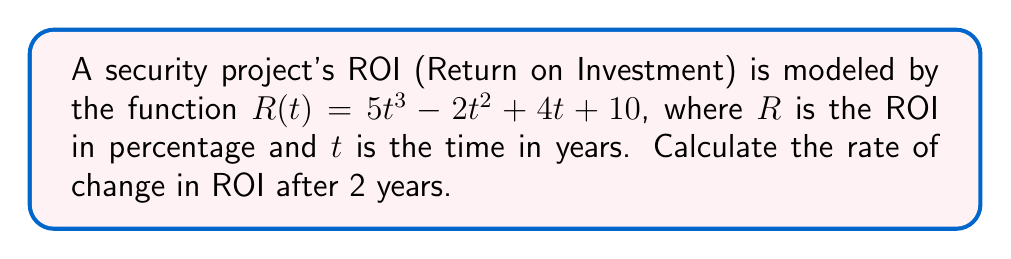Help me with this question. To find the rate of change in ROI after 2 years, we need to calculate the derivative of the ROI function and evaluate it at $t = 2$. Here's the step-by-step process:

1. Given ROI function: $R(t) = 5t^3 - 2t^2 + 4t + 10$

2. Calculate the derivative $R'(t)$:
   $$R'(t) = \frac{d}{dt}(5t^3 - 2t^2 + 4t + 10)$$
   $$R'(t) = 15t^2 - 4t + 4$$

3. Evaluate $R'(t)$ at $t = 2$:
   $$R'(2) = 15(2)^2 - 4(2) + 4$$
   $$R'(2) = 15(4) - 8 + 4$$
   $$R'(2) = 60 - 8 + 4$$
   $$R'(2) = 56$$

The rate of change in ROI after 2 years is 56 percentage points per year.
Answer: 56 percentage points per year 